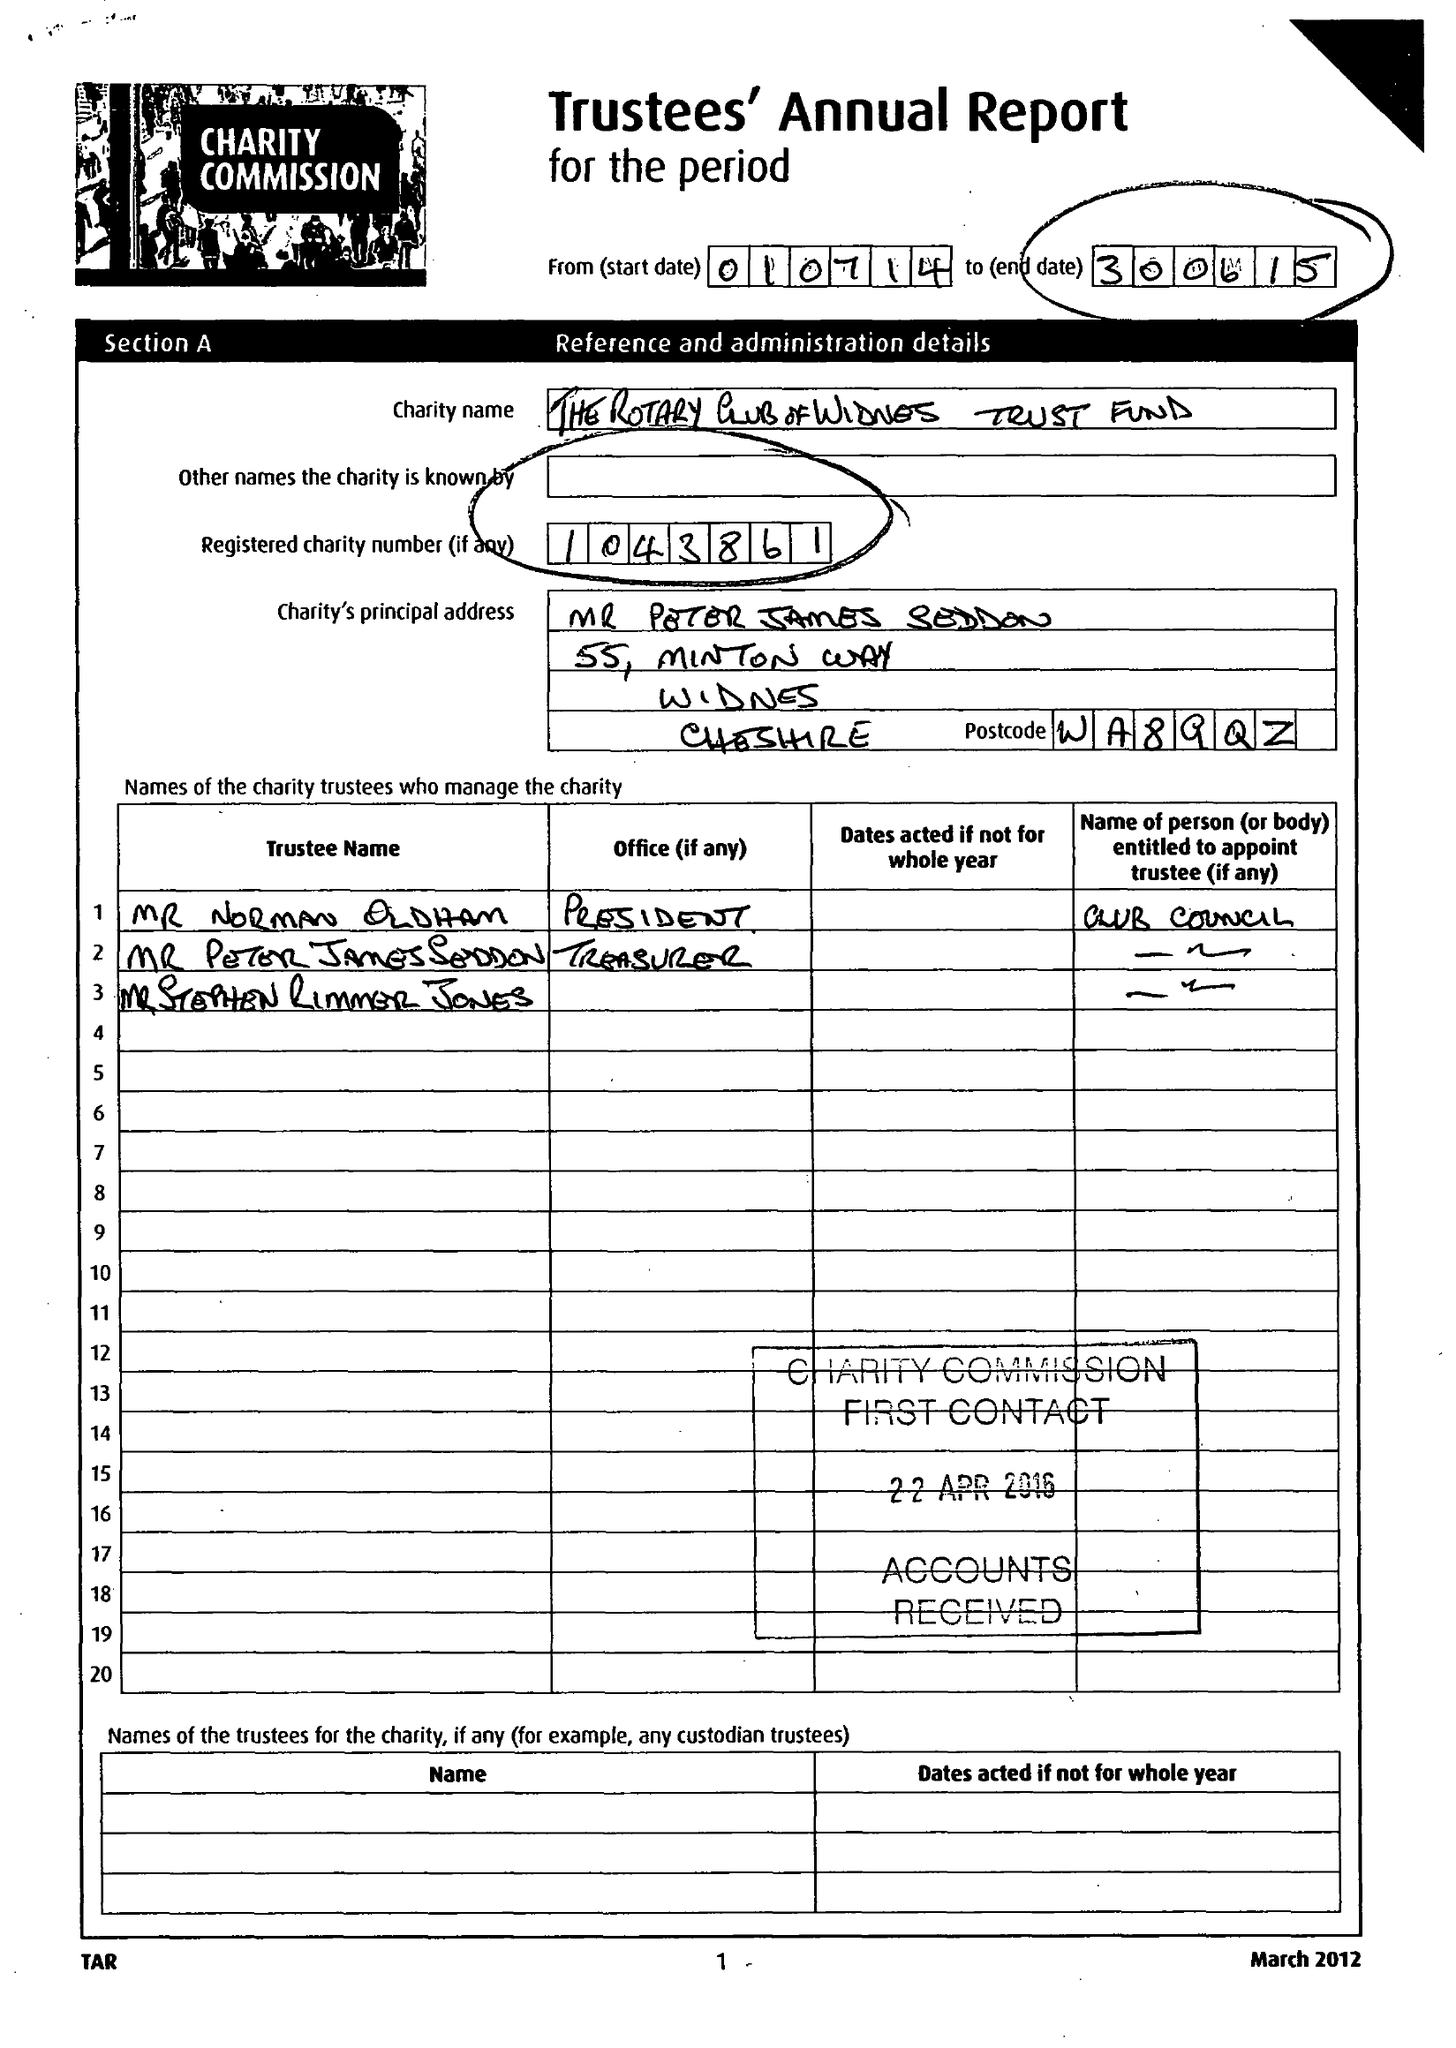What is the value for the income_annually_in_british_pounds?
Answer the question using a single word or phrase. 59014.39 